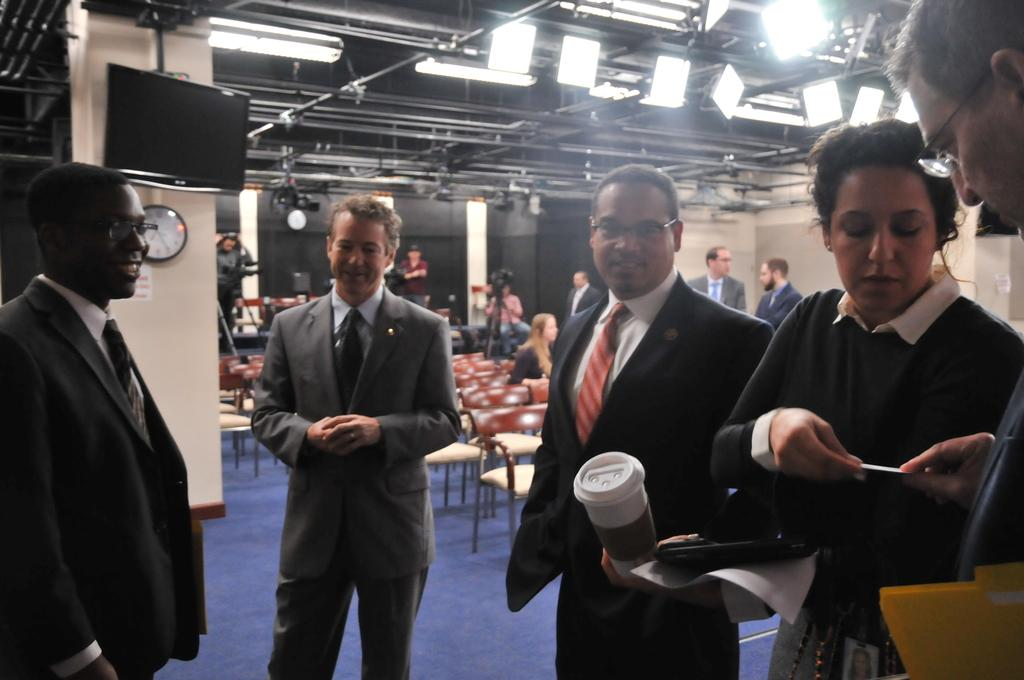What are the people in the image doing? The people in the image are standing. What is the man holding in the image? The man is holding a glass. Can you describe the background of the image? In the background of the image, there are people, chairs, lights, a television, and a clock on a pillar. What type of frog can be seen jumping on the ground in the image? There is no frog present in the image, and the ground is not visible. 